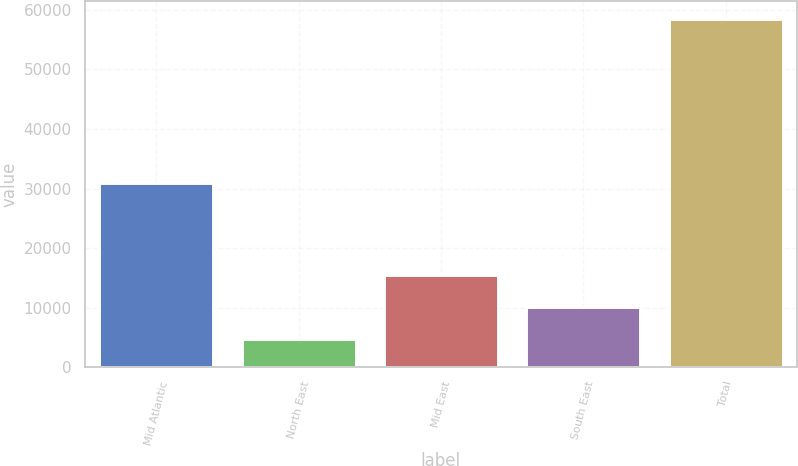Convert chart. <chart><loc_0><loc_0><loc_500><loc_500><bar_chart><fcel>Mid Atlantic<fcel>North East<fcel>Mid East<fcel>South East<fcel>Total<nl><fcel>30969<fcel>4772<fcel>15517.2<fcel>10144.6<fcel>58498<nl></chart> 